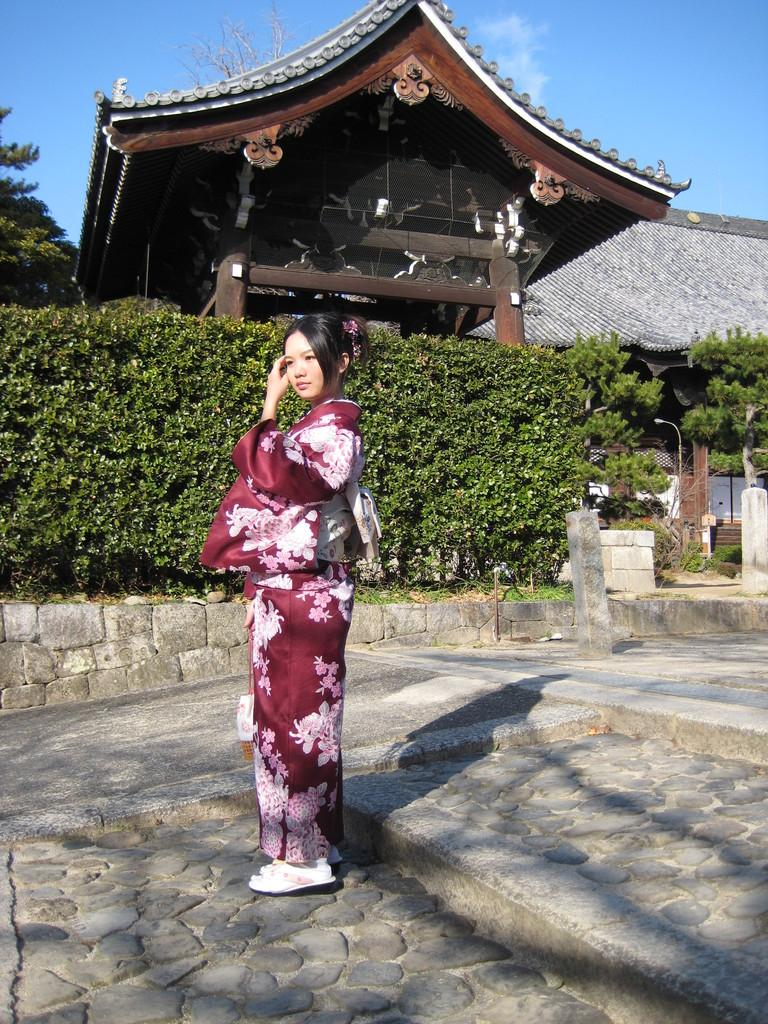Who is the main subject in the image? There is a Chinese girl in the image. What is the girl wearing? The girl is wearing a red dress. What type of surface is the girl standing on? The girl is standing on cobbler stones. What can be seen in the background of the image? There are green plants and a roofing tile house in the background of the image. What type of lace is used to decorate the girl's dress in the image? There is no lace visible on the girl's dress in the image. Can you tell me how the girl is interacting with the space station in the image? There is no space station present in the image; it features a Chinese girl standing on cobbler stones with a background of green plants and a roofing tile house. 